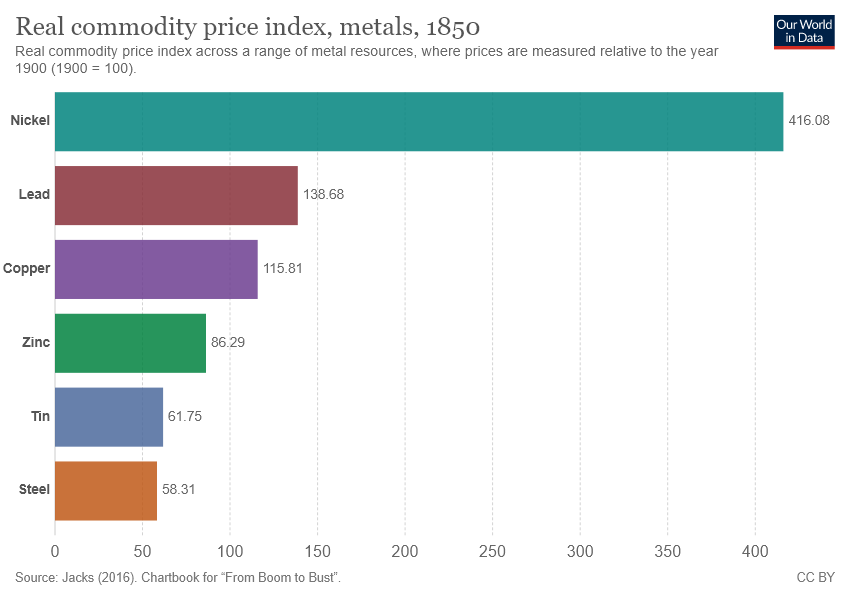Draw attention to some important aspects in this diagram. Nickel has the highest real commodity price index among all metals, indicating that it is currently the most expensive metal in terms of its purchasing power. To determine the average real commodity price index of bar values that are lower than 80, we calculated 60.03. 